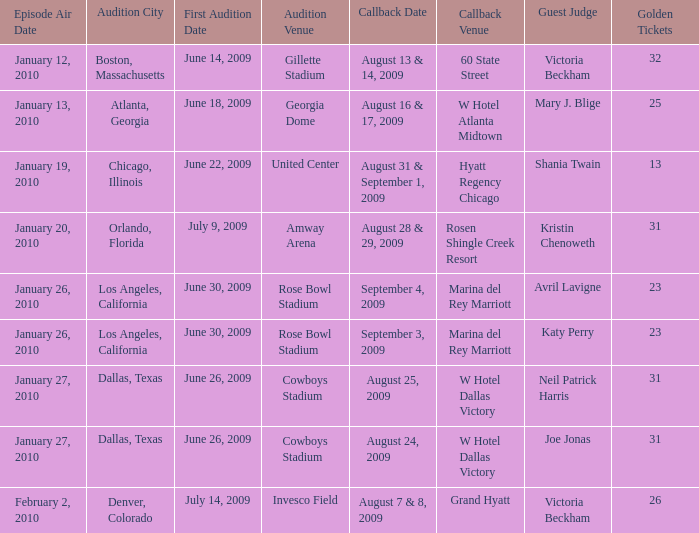Specify the golden admission for invesco field. 26.0. 